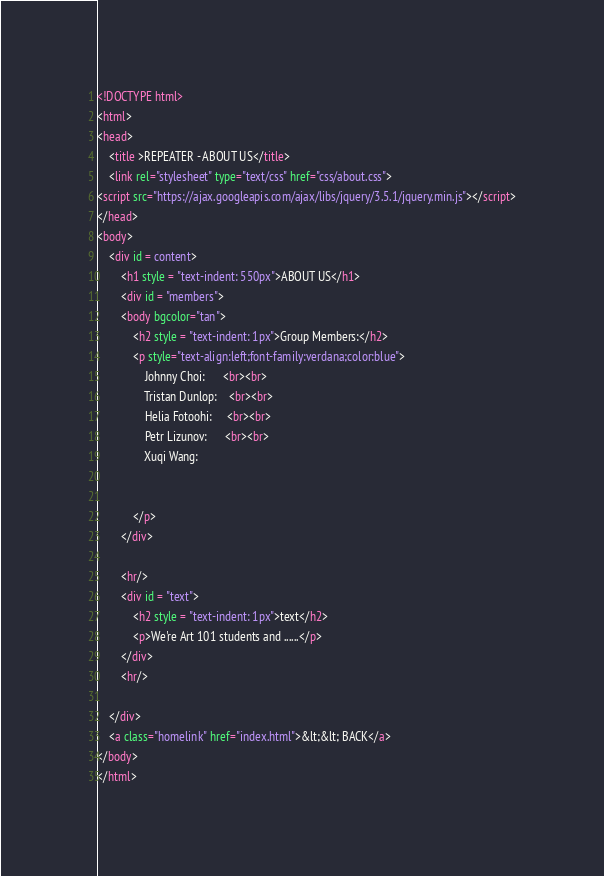Convert code to text. <code><loc_0><loc_0><loc_500><loc_500><_HTML_><!DOCTYPE html>
<html>
<head>
	<title >REPEATER - ABOUT US</title>
	<link rel="stylesheet" type="text/css" href="css/about.css">
<script src="https://ajax.googleapis.com/ajax/libs/jquery/3.5.1/jquery.min.js"></script>
</head>
<body>
	<div id = content>
		<h1 style = "text-indent: 550px">ABOUT US</h1>
		<div id = "members">
		<body bgcolor="tan">
			<h2 style = "text-indent: 1px">Group Members:</h2>
			<p style="text-align:left;font-family:verdana;color:blue">
				Johnny Choi:      <br><br>
				Tristan Dunlop:    <br><br>
				Helia Fotoohi:     <br><br>
				Petr Lizunov:      <br><br>
				Xuqi Wang:


			</p>
		</div>

		<hr/>
		<div id = "text">
			<h2 style = "text-indent: 1px">text</h2>
			<p>We're Art 101 students and ......</p>
		</div>
		<hr/>

	</div>
	<a class="homelink" href="index.html">&lt;&lt; BACK</a>
</body>
</html>
</code> 